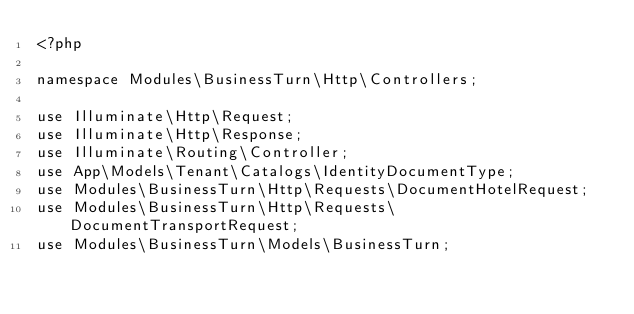Convert code to text. <code><loc_0><loc_0><loc_500><loc_500><_PHP_><?php

namespace Modules\BusinessTurn\Http\Controllers;

use Illuminate\Http\Request;
use Illuminate\Http\Response;
use Illuminate\Routing\Controller;
use App\Models\Tenant\Catalogs\IdentityDocumentType;
use Modules\BusinessTurn\Http\Requests\DocumentHotelRequest;
use Modules\BusinessTurn\Http\Requests\DocumentTransportRequest;
use Modules\BusinessTurn\Models\BusinessTurn;</code> 